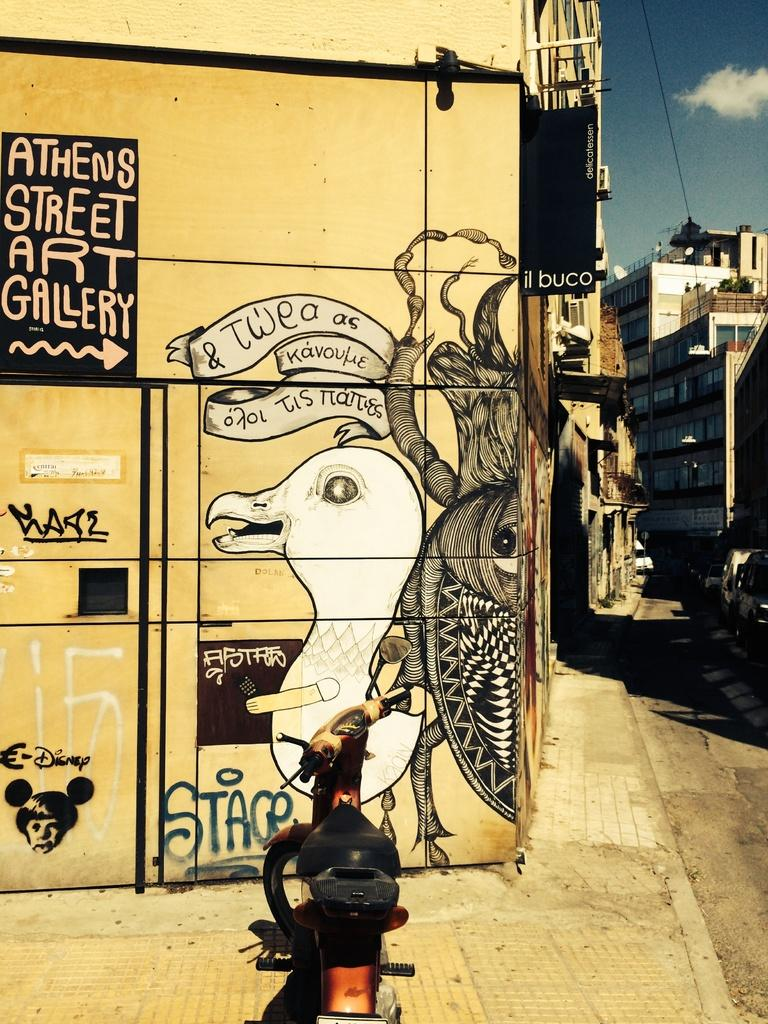<image>
Relay a brief, clear account of the picture shown. Wall full of grafitti and the name "STAGE" on the bottom. 